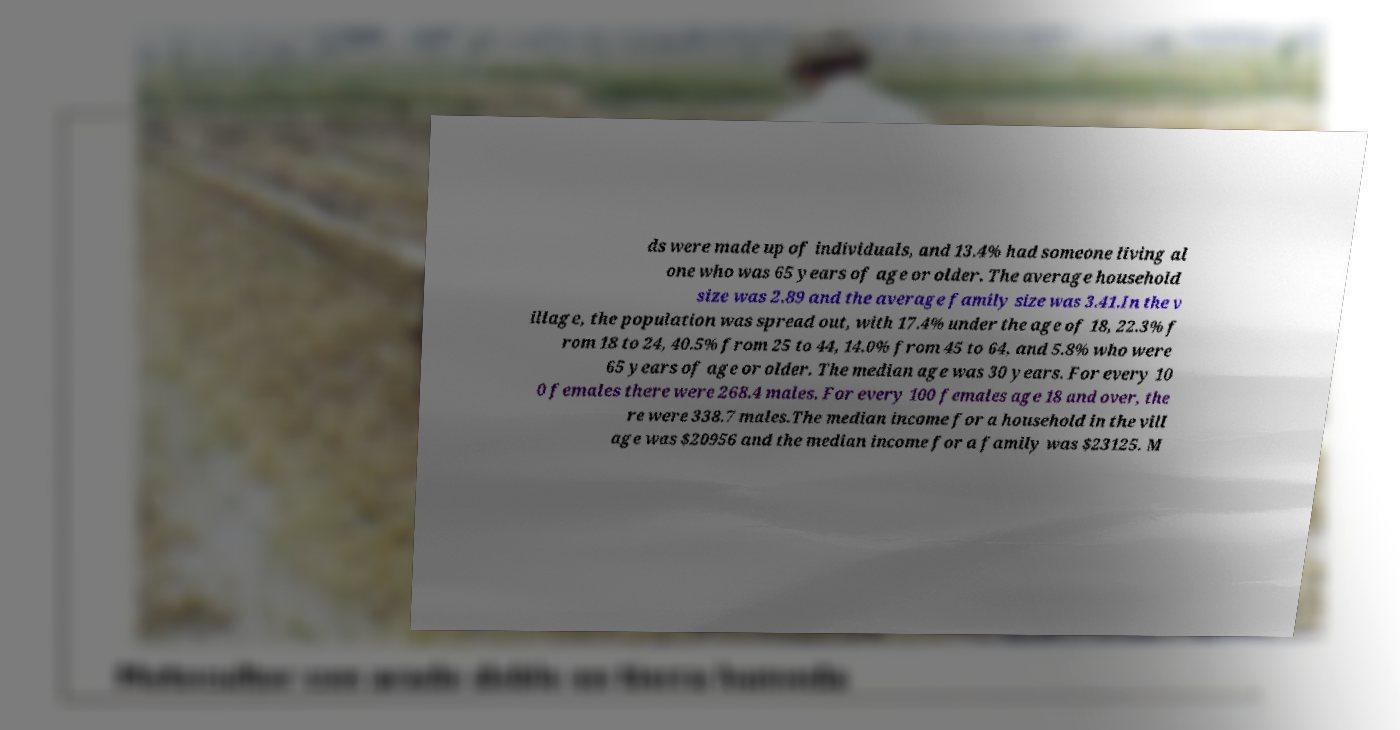I need the written content from this picture converted into text. Can you do that? ds were made up of individuals, and 13.4% had someone living al one who was 65 years of age or older. The average household size was 2.89 and the average family size was 3.41.In the v illage, the population was spread out, with 17.4% under the age of 18, 22.3% f rom 18 to 24, 40.5% from 25 to 44, 14.0% from 45 to 64, and 5.8% who were 65 years of age or older. The median age was 30 years. For every 10 0 females there were 268.4 males. For every 100 females age 18 and over, the re were 338.7 males.The median income for a household in the vill age was $20956 and the median income for a family was $23125. M 